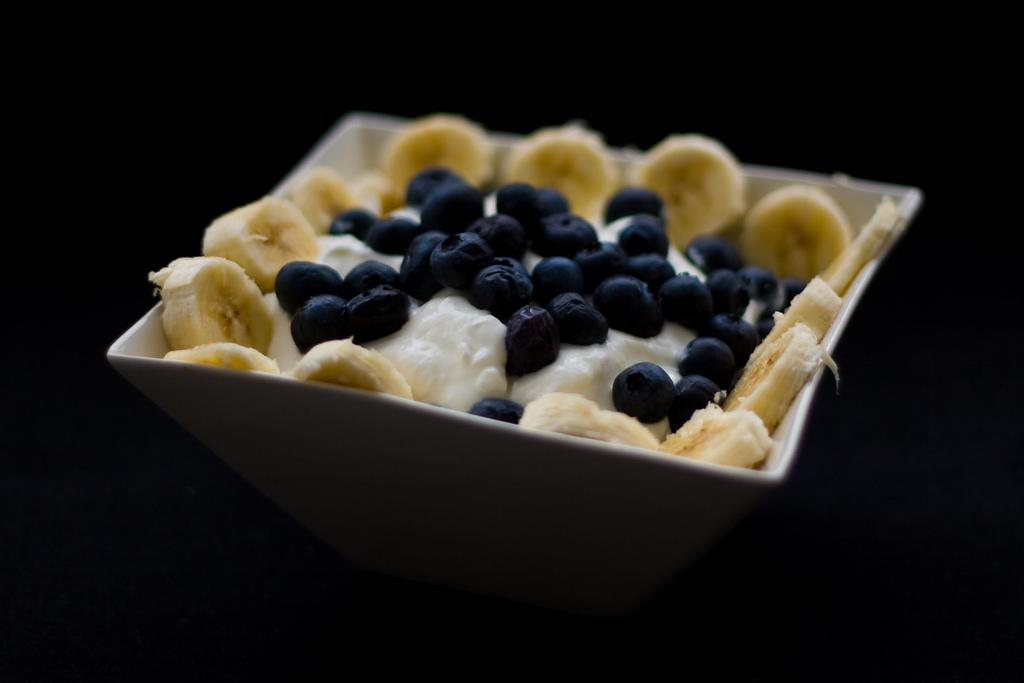What types of food are in the bowl in the image? There is cheese, banana pieces, and berries in the bowl. Can you describe the different ingredients in the bowl? The bowl contains cheese, banana pieces, and berries. What type of crown is placed on top of the cheese in the image? There is no crown present in the image; it is a bowl of cheese, banana pieces, and berries. 